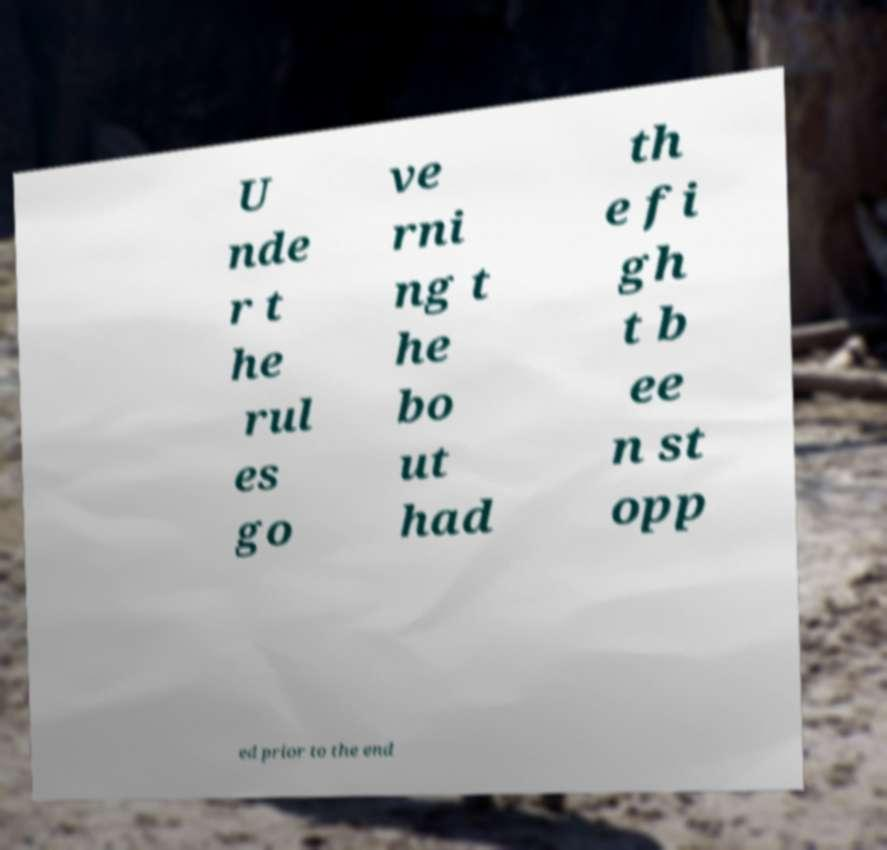Could you assist in decoding the text presented in this image and type it out clearly? U nde r t he rul es go ve rni ng t he bo ut had th e fi gh t b ee n st opp ed prior to the end 